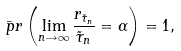Convert formula to latex. <formula><loc_0><loc_0><loc_500><loc_500>\bar { \ p r } \left ( \lim _ { n \rightarrow \infty } \frac { r _ { \tilde { \tau } _ { n } } } { \tilde { \tau } _ { n } } = \alpha \right ) = 1 ,</formula> 